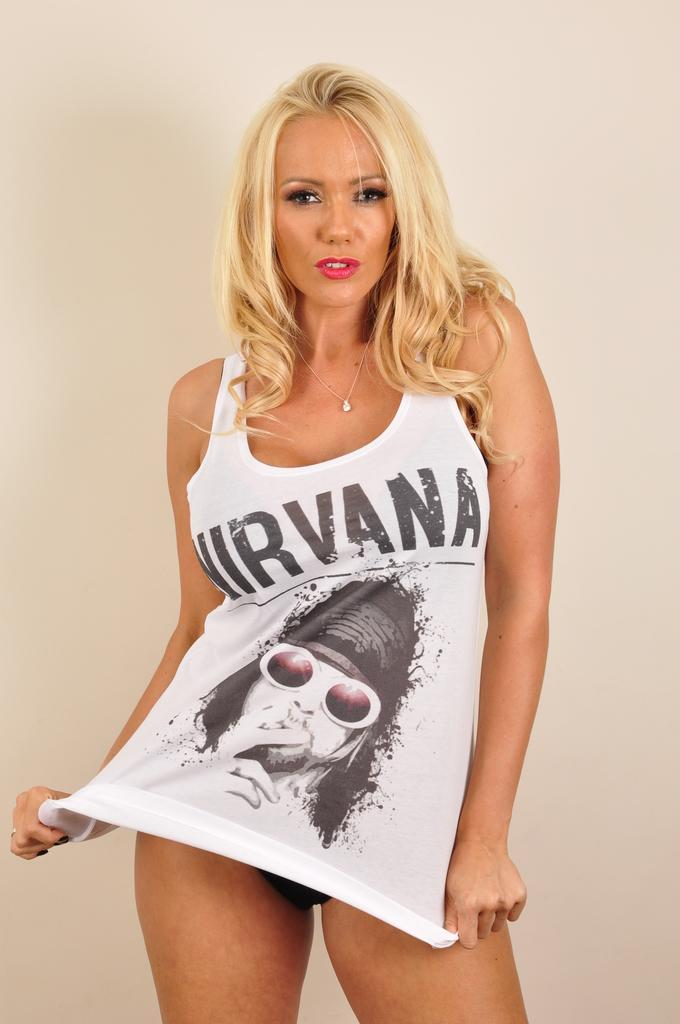Who is present in the image? There is a woman in the image. How many tomatoes are being used as an example in the image? There are no tomatoes present in the image. What type of connection can be seen between the woman and the tomatoes in the image? There are no tomatoes or connections involving tomatoes in the image, as it only features a woman. 